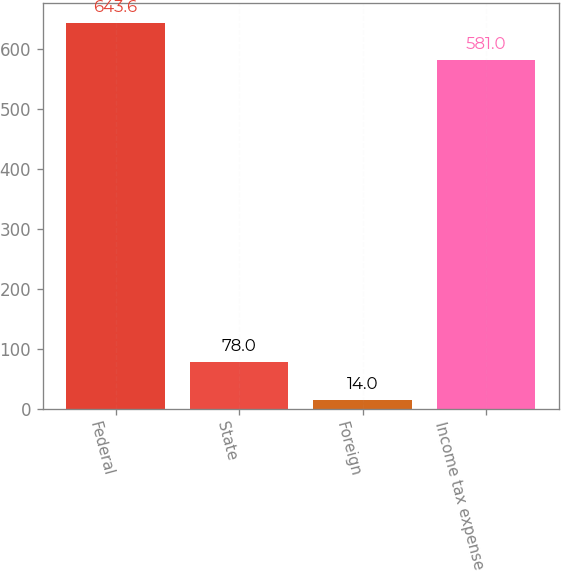Convert chart. <chart><loc_0><loc_0><loc_500><loc_500><bar_chart><fcel>Federal<fcel>State<fcel>Foreign<fcel>Income tax expense<nl><fcel>643.6<fcel>78<fcel>14<fcel>581<nl></chart> 